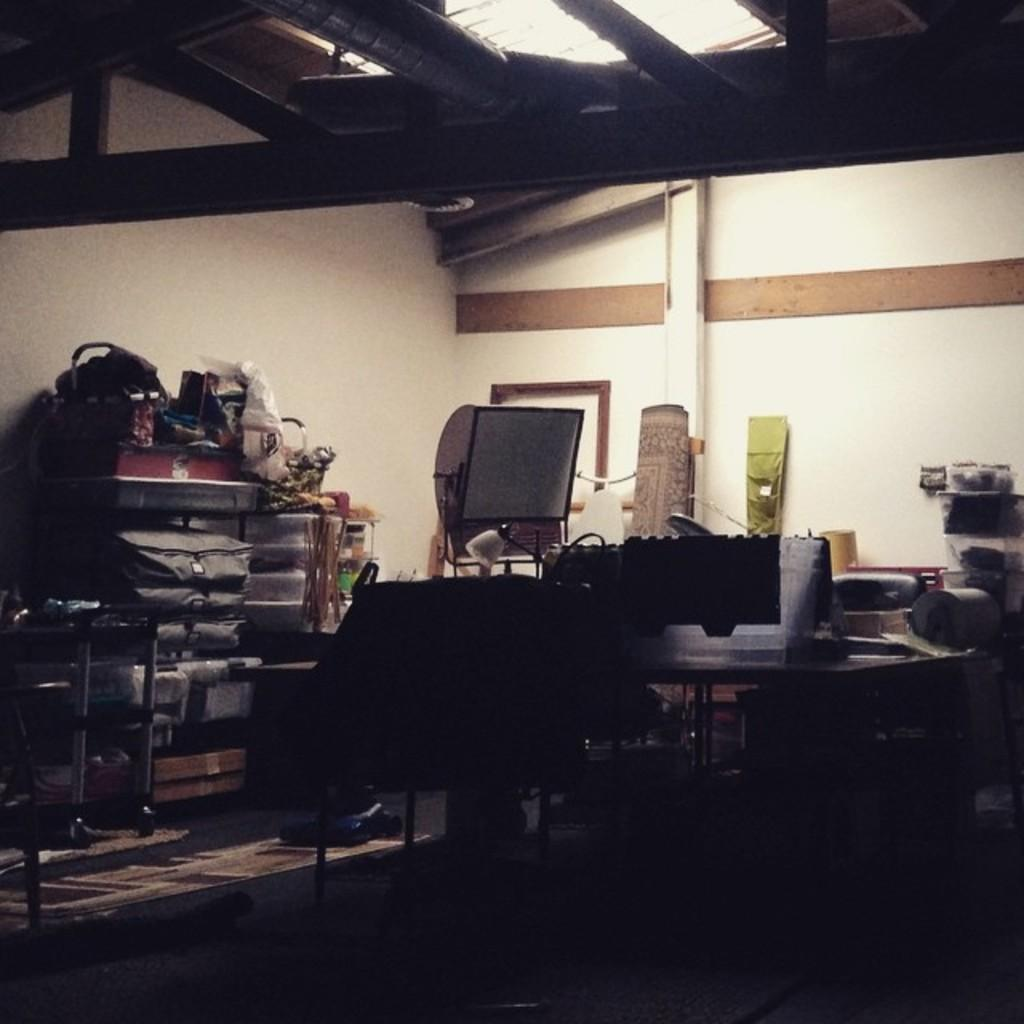Where was the image taken? The image was taken inside a house. What can be observed in the image? There are many objects in the image. Can you describe the arrangement of some of the objects? There are objects placed on a rack in the image. What is visible at the top of the image? There are lights at the top of the image. What type of oranges are being harvested in the image? There are no oranges or any indication of harvesting in the image. 